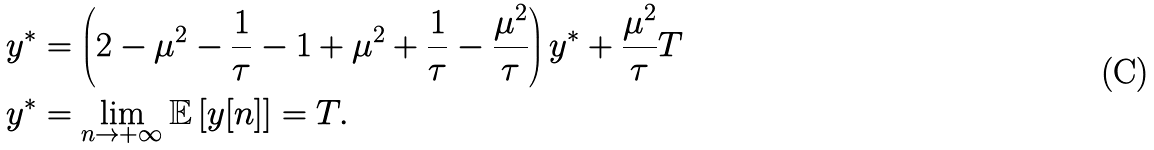Convert formula to latex. <formula><loc_0><loc_0><loc_500><loc_500>y ^ { * } & = \left ( 2 - \mu ^ { 2 } - \frac { 1 } { \tau } - 1 + \mu ^ { 2 } + \frac { 1 } { \tau } - \frac { \mu ^ { 2 } } { \tau } \right ) y ^ { * } + \frac { \mu ^ { 2 } } { \tau } T \\ y ^ { * } & = \lim _ { n \rightarrow + \infty } \mathbb { E } \left [ y [ n ] \right ] = T .</formula> 